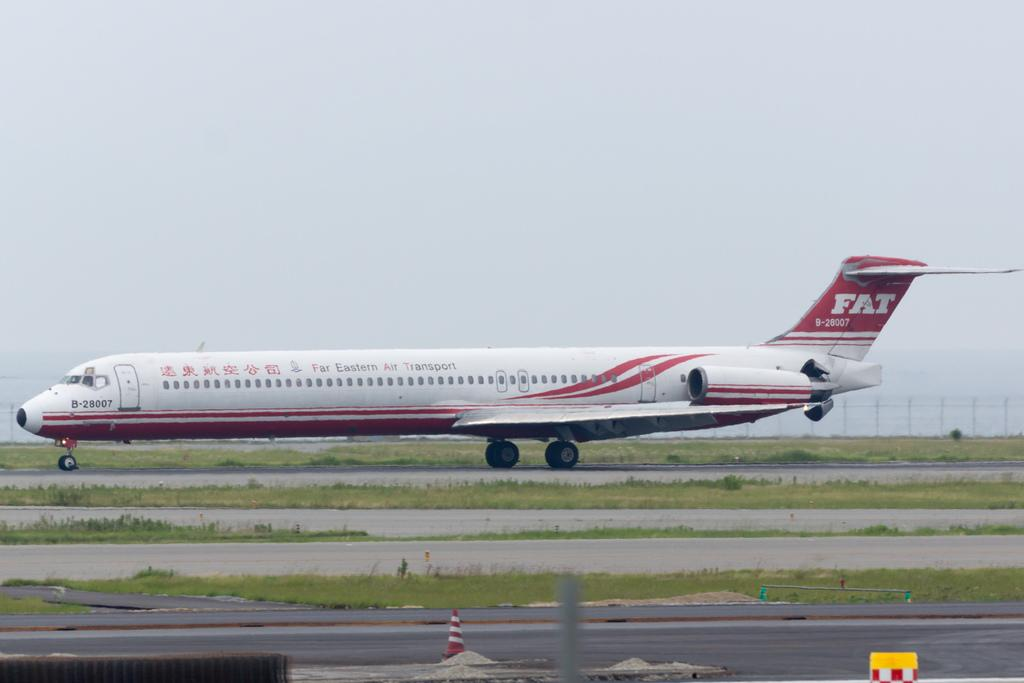<image>
Render a clear and concise summary of the photo. A plane sits on an old runway and has the word FAT on the tail. 